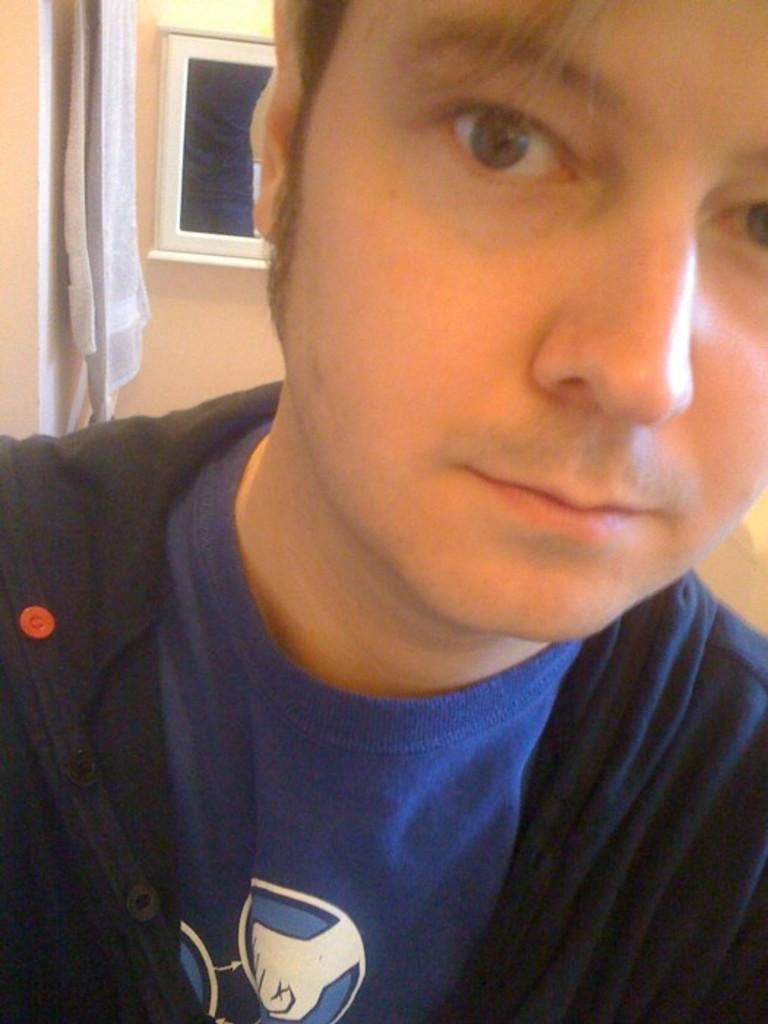What is the setting of the image? The image is of a room. Can you describe the person in the room? There is a person in the room wearing a blue t-shirt. What object can be seen at the back of the room? There is a device at the back of the room. What is hanging on the wall in the room? There is a towel on the wall in the room. What type of thrill can be heard coming from the device in the image? There is no indication of any sound or thrill coming from the device in the image. The device could be anything from a television to a speaker, but we cannot determine its function or purpose based on the image alone. 